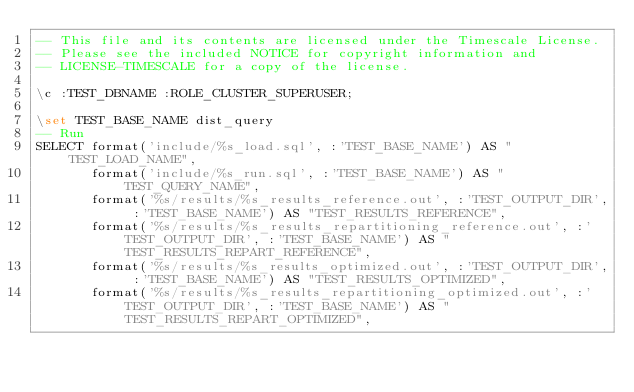<code> <loc_0><loc_0><loc_500><loc_500><_SQL_>-- This file and its contents are licensed under the Timescale License.
-- Please see the included NOTICE for copyright information and
-- LICENSE-TIMESCALE for a copy of the license.

\c :TEST_DBNAME :ROLE_CLUSTER_SUPERUSER;

\set TEST_BASE_NAME dist_query
-- Run
SELECT format('include/%s_load.sql', :'TEST_BASE_NAME') AS "TEST_LOAD_NAME",
       format('include/%s_run.sql', :'TEST_BASE_NAME') AS "TEST_QUERY_NAME",
       format('%s/results/%s_results_reference.out', :'TEST_OUTPUT_DIR', :'TEST_BASE_NAME') AS "TEST_RESULTS_REFERENCE",
       format('%s/results/%s_results_repartitioning_reference.out', :'TEST_OUTPUT_DIR', :'TEST_BASE_NAME') AS "TEST_RESULTS_REPART_REFERENCE",
       format('%s/results/%s_results_optimized.out', :'TEST_OUTPUT_DIR', :'TEST_BASE_NAME') AS "TEST_RESULTS_OPTIMIZED",
       format('%s/results/%s_results_repartitioning_optimized.out', :'TEST_OUTPUT_DIR', :'TEST_BASE_NAME') AS "TEST_RESULTS_REPART_OPTIMIZED",</code> 